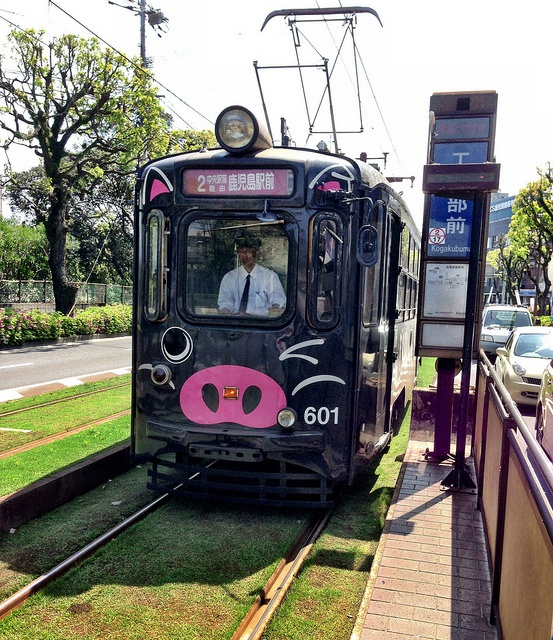Describe the objects in this image and their specific colors. I can see train in white, black, gray, and darkgray tones, people in white, darkgray, gray, and black tones, car in white, darkgray, and gray tones, car in white, darkgray, and gray tones, and car in white, darkgray, tan, ivory, and black tones in this image. 